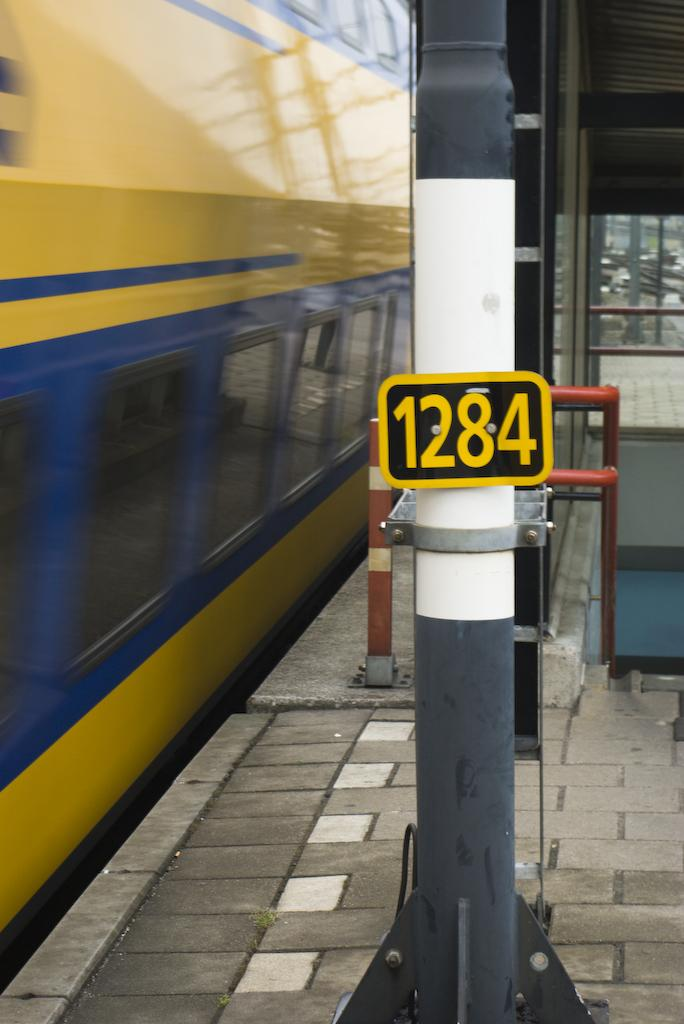<image>
Render a clear and concise summary of the photo. The black and yellow sign states that this is stop 1284. 